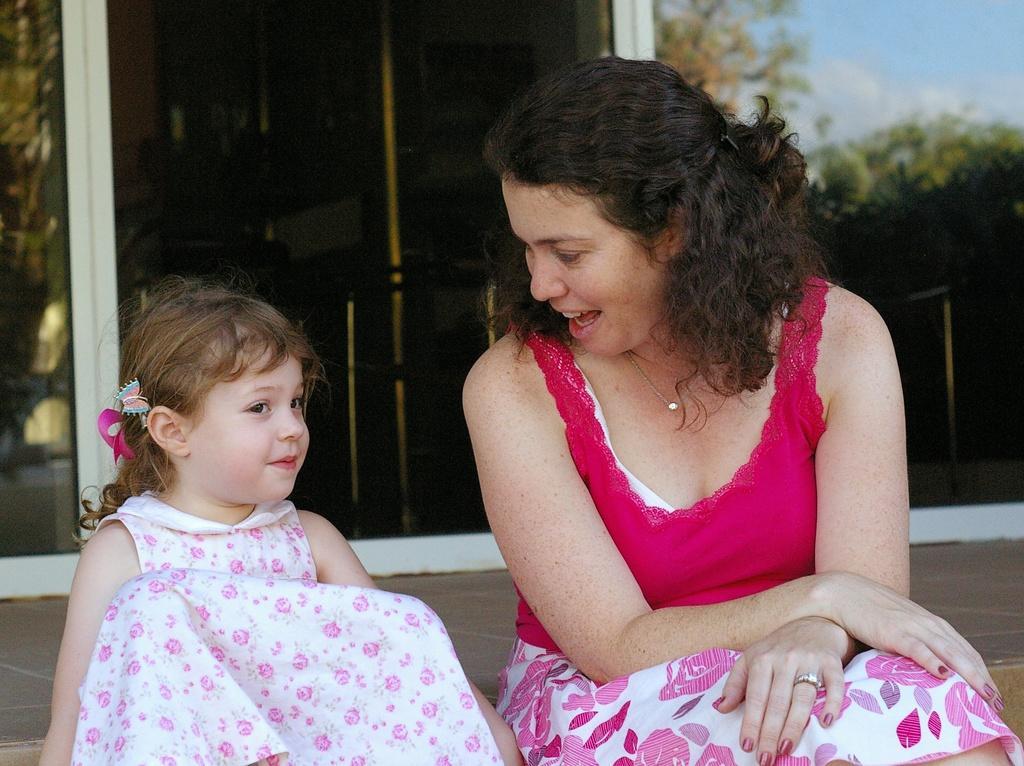Describe this image in one or two sentences. In this picture I can see a woman and a girl sitting , and in the background there are some items, and there is a reflection of trees and sky. 